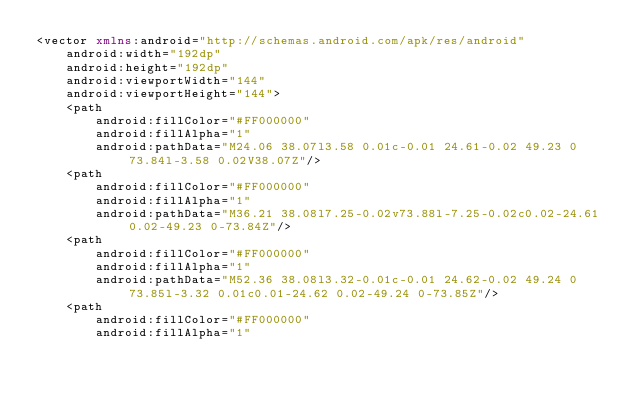Convert code to text. <code><loc_0><loc_0><loc_500><loc_500><_XML_><vector xmlns:android="http://schemas.android.com/apk/res/android"
    android:width="192dp"
    android:height="192dp"
    android:viewportWidth="144"
    android:viewportHeight="144">
    <path
        android:fillColor="#FF000000"
        android:fillAlpha="1"
        android:pathData="M24.06 38.07l3.58 0.01c-0.01 24.61-0.02 49.23 0 73.84l-3.58 0.02V38.07Z"/>
    <path
        android:fillColor="#FF000000"
        android:fillAlpha="1"
        android:pathData="M36.21 38.08l7.25-0.02v73.88l-7.25-0.02c0.02-24.61 0.02-49.23 0-73.84Z"/>
    <path
        android:fillColor="#FF000000"
        android:fillAlpha="1"
        android:pathData="M52.36 38.08l3.32-0.01c-0.01 24.62-0.02 49.24 0 73.85l-3.32 0.01c0.01-24.62 0.02-49.24 0-73.85Z"/>
    <path
        android:fillColor="#FF000000"
        android:fillAlpha="1"</code> 